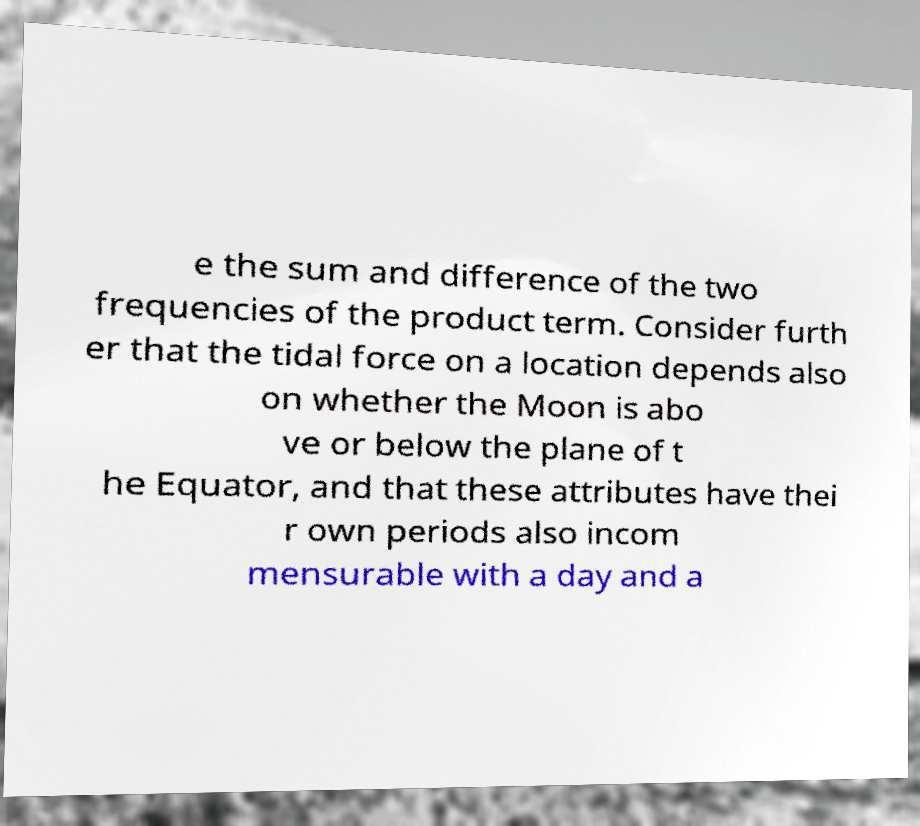Please read and relay the text visible in this image. What does it say? e the sum and difference of the two frequencies of the product term. Consider furth er that the tidal force on a location depends also on whether the Moon is abo ve or below the plane of t he Equator, and that these attributes have thei r own periods also incom mensurable with a day and a 